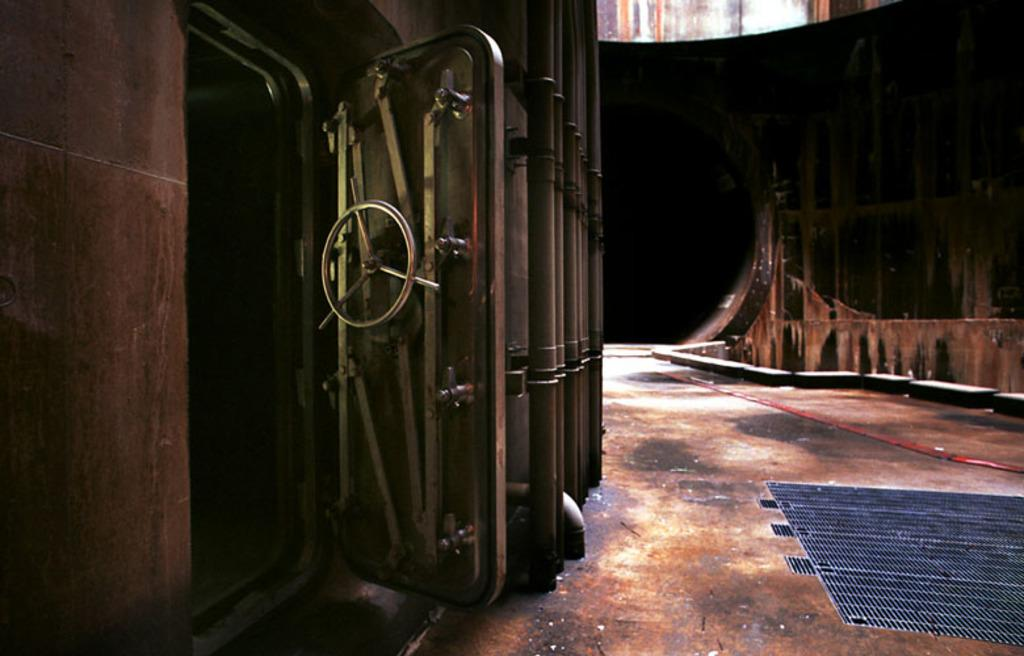What is the primary surface visible in the image? There is a ground in the image. What type of door is depicted in the image? There is a door with a wheel in the image. How would you describe the overall lighting in the image? The background of the image is dark. How does the ray of sunshine affect the door in the image? There is no ray of sunshine present in the image; the background is dark. 